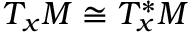Convert formula to latex. <formula><loc_0><loc_0><loc_500><loc_500>T _ { x } M \cong T _ { x } ^ { * } M</formula> 